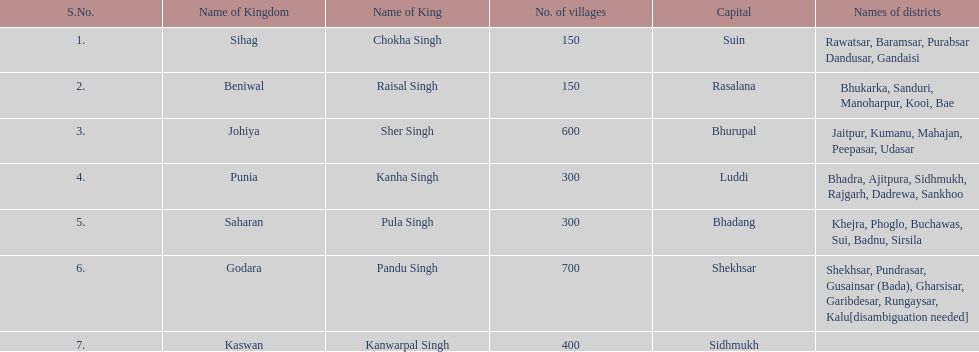How many kingdoms are listed? 7. 